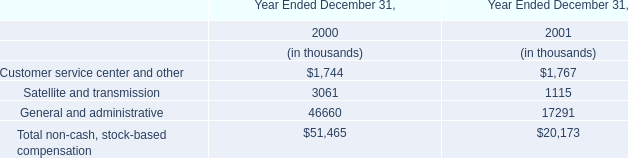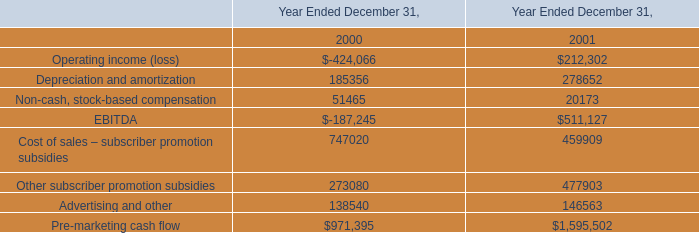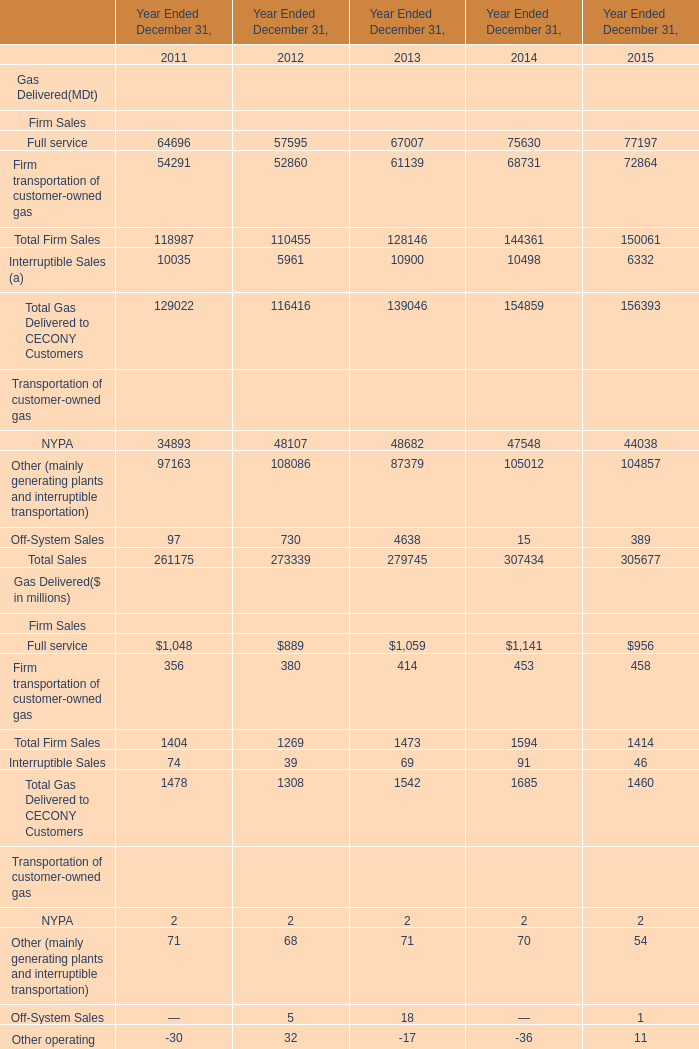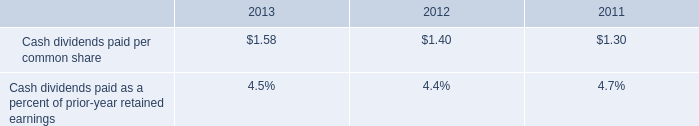how many share were outstanding in 2013 based on the amount paid for dividends? 
Computations: ((92.0 * 1000000) / 1.58)
Answer: 58227848.10127. 